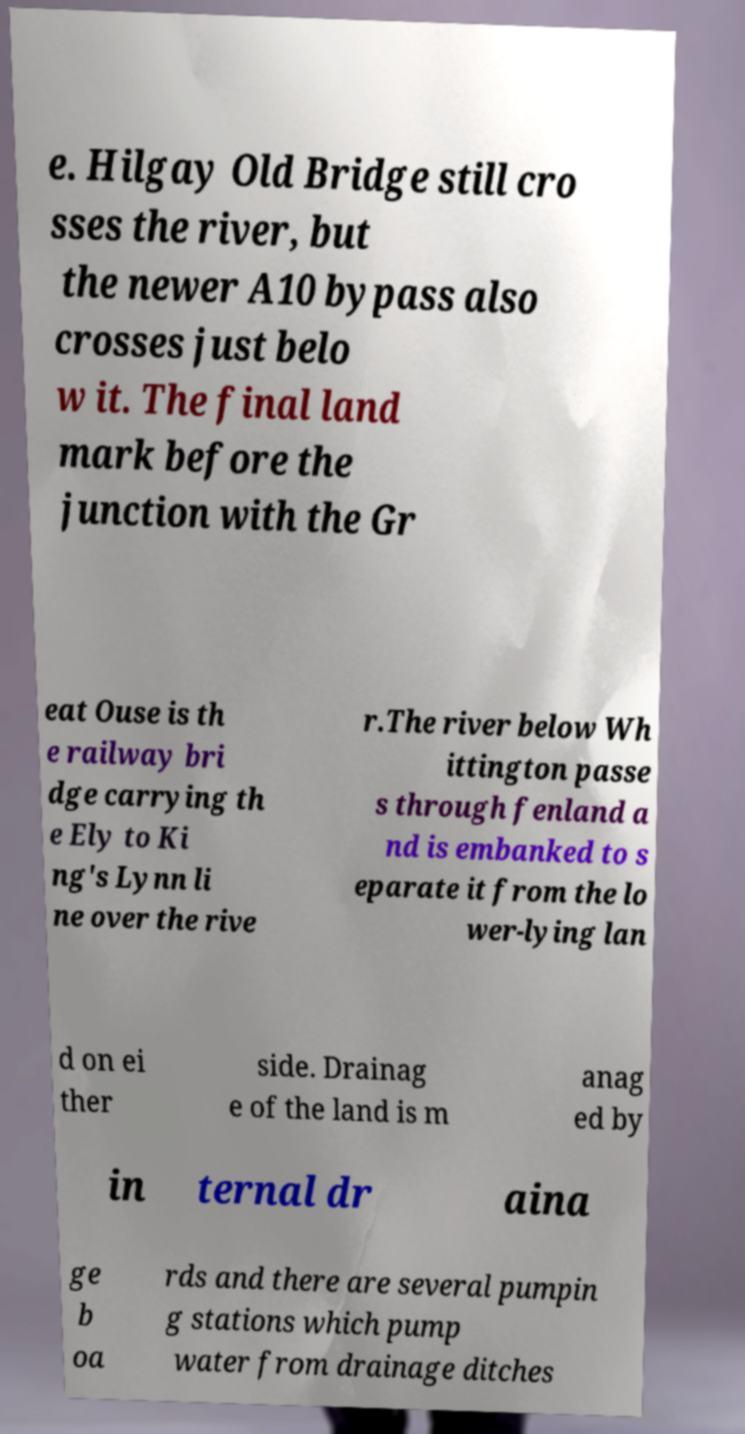Please read and relay the text visible in this image. What does it say? e. Hilgay Old Bridge still cro sses the river, but the newer A10 bypass also crosses just belo w it. The final land mark before the junction with the Gr eat Ouse is th e railway bri dge carrying th e Ely to Ki ng's Lynn li ne over the rive r.The river below Wh ittington passe s through fenland a nd is embanked to s eparate it from the lo wer-lying lan d on ei ther side. Drainag e of the land is m anag ed by in ternal dr aina ge b oa rds and there are several pumpin g stations which pump water from drainage ditches 